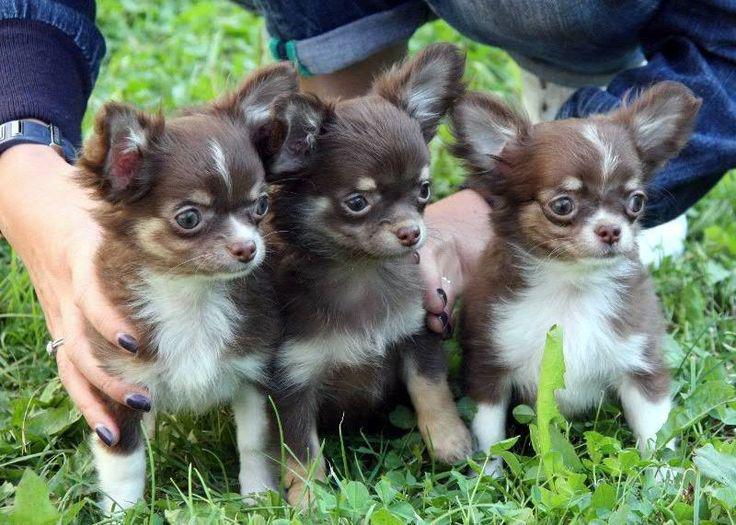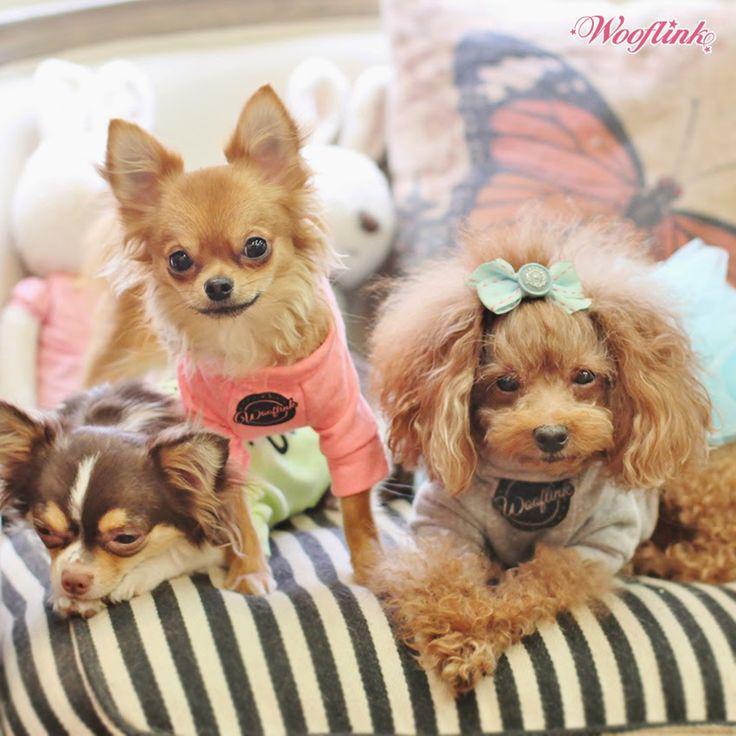The first image is the image on the left, the second image is the image on the right. Considering the images on both sides, is "Only one image shows dogs wearing some kind of attire besides an ordinary dog collar." valid? Answer yes or no. Yes. The first image is the image on the left, the second image is the image on the right. Evaluate the accuracy of this statement regarding the images: "One of the images shows exactly two dogs.". Is it true? Answer yes or no. No. The first image is the image on the left, the second image is the image on the right. For the images shown, is this caption "An equal number of puppies are in each image." true? Answer yes or no. Yes. 